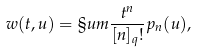Convert formula to latex. <formula><loc_0><loc_0><loc_500><loc_500>w ( t , u ) = \S u m \frac { t ^ { n } } { [ n ] _ { q } ! } p _ { n } ( u ) ,</formula> 